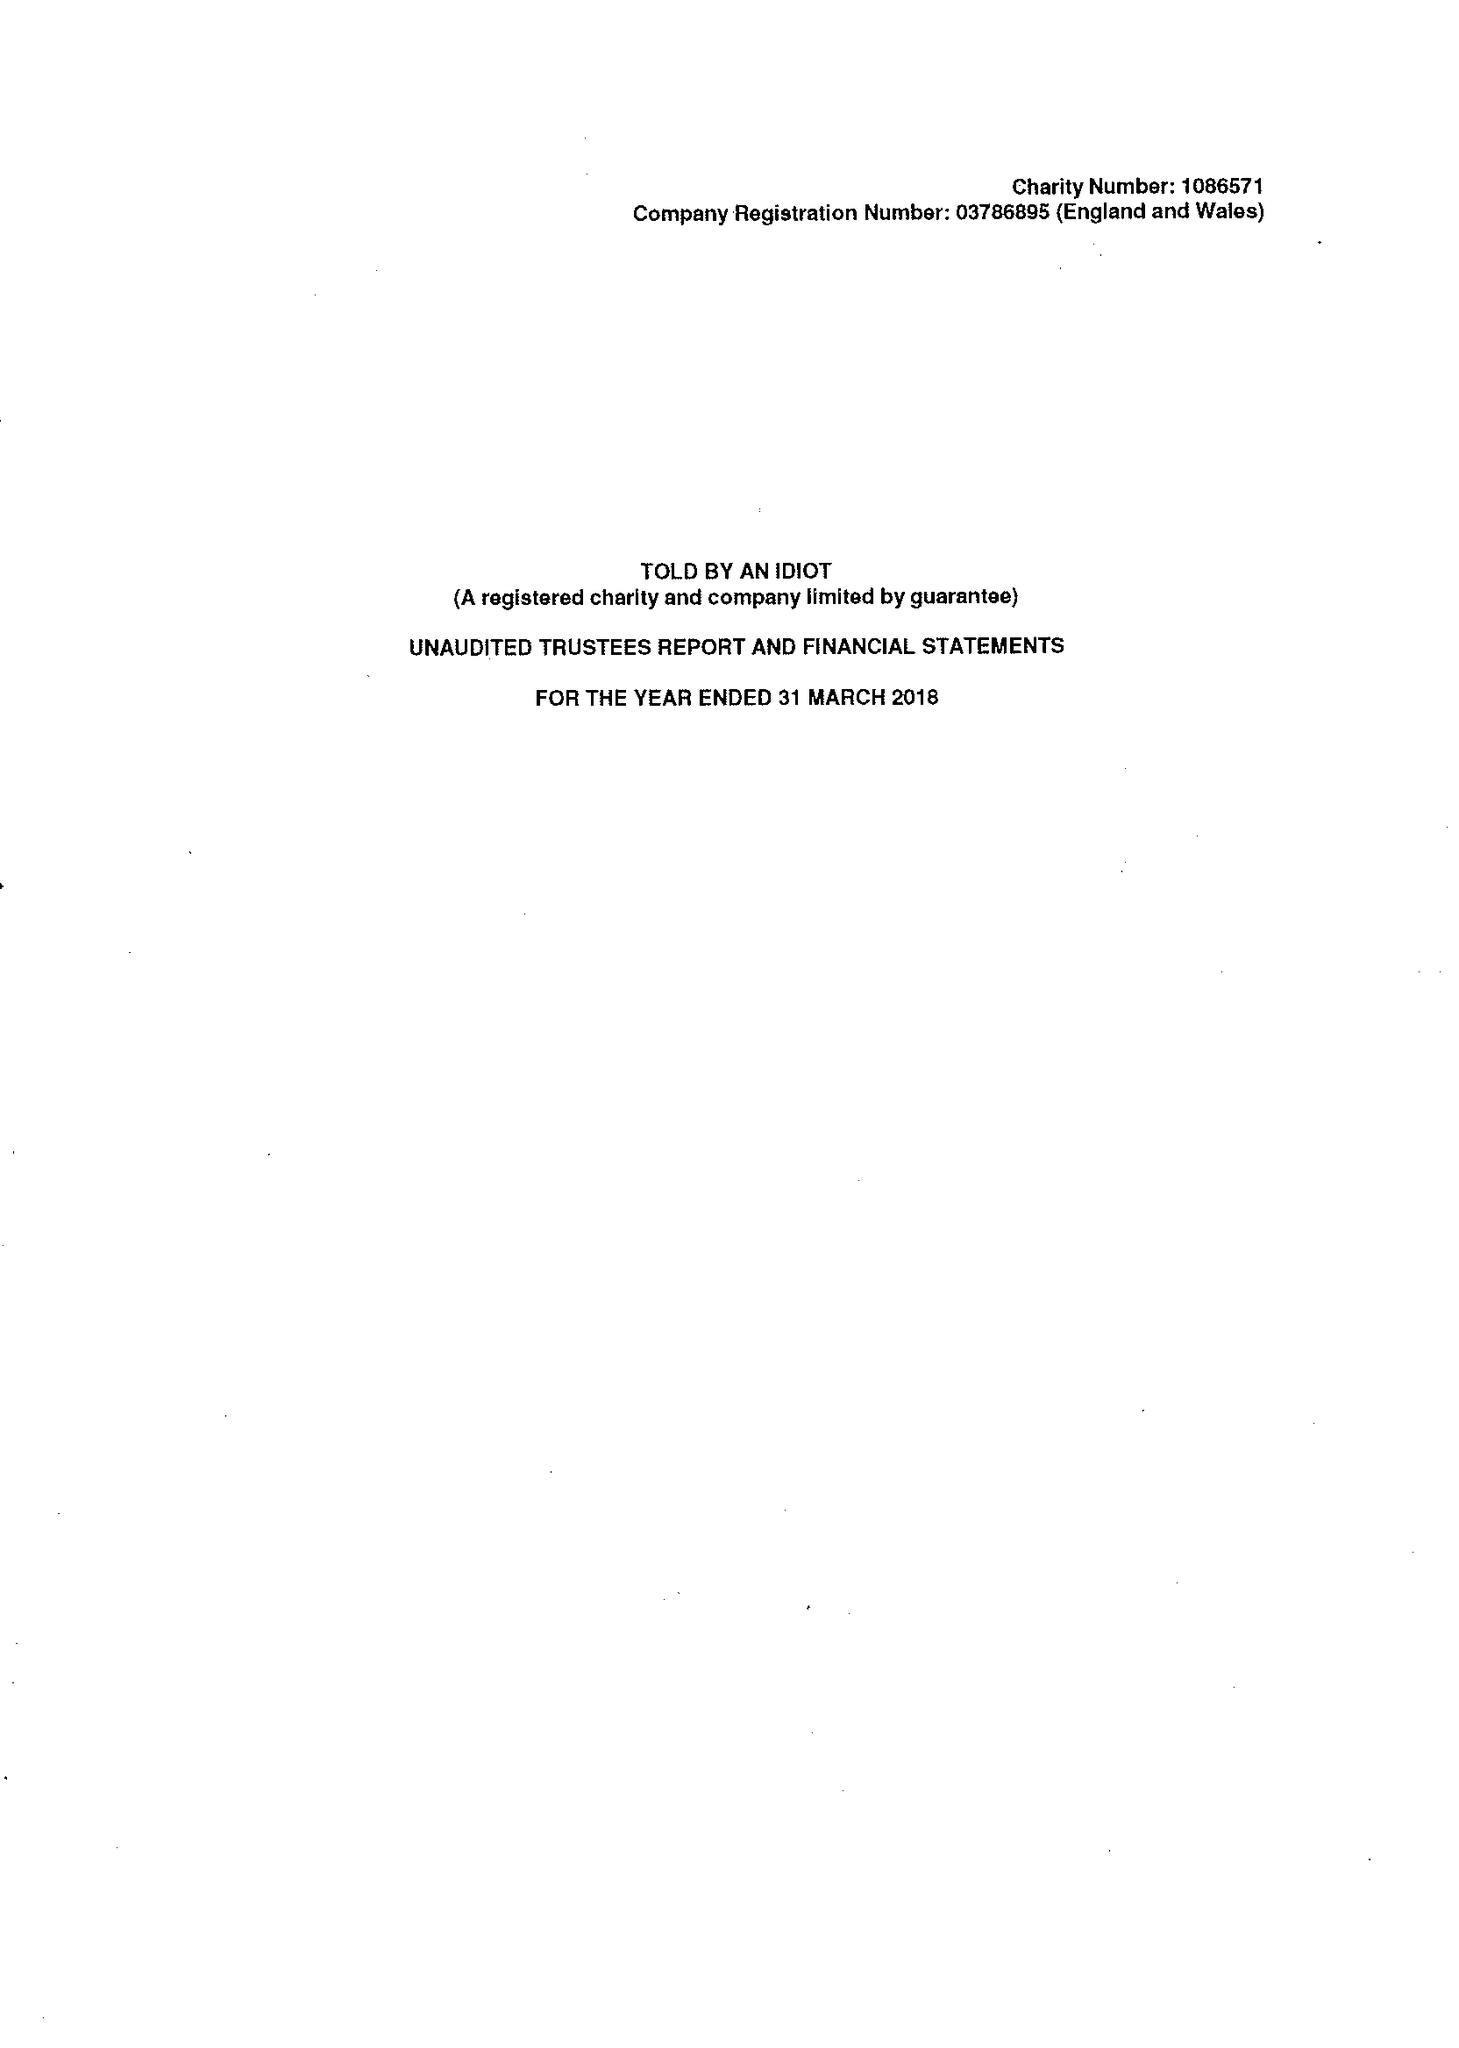What is the value for the address__street_line?
Answer the question using a single word or phrase. 59 ST MARTIN'S LANE 